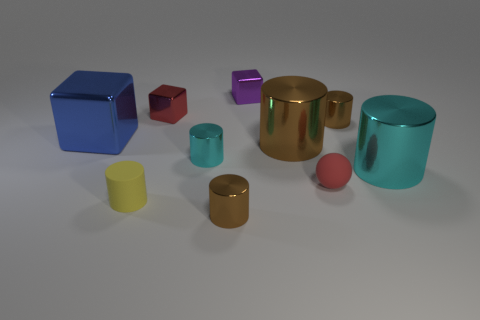Are there fewer blue matte objects than shiny objects?
Give a very brief answer. Yes. There is a red object that is behind the large block; is it the same size as the brown cylinder in front of the red rubber ball?
Give a very brief answer. Yes. What number of things are large cyan matte things or metallic cylinders?
Make the answer very short. 5. There is a cyan metal cylinder left of the tiny purple block; what is its size?
Your response must be concise. Small. What number of big metallic cylinders are to the left of the object that is to the left of the matte thing that is to the left of the purple object?
Make the answer very short. 0. Does the tiny rubber sphere have the same color as the large block?
Make the answer very short. No. What number of metal objects are left of the small red matte thing and behind the blue block?
Provide a succinct answer. 2. There is a large object in front of the small cyan metallic cylinder; what shape is it?
Make the answer very short. Cylinder. Is the number of cubes that are in front of the small cyan object less than the number of small blocks that are in front of the purple metallic cube?
Your answer should be very brief. Yes. Is the material of the small brown cylinder that is to the right of the small ball the same as the red block that is behind the sphere?
Offer a very short reply. Yes. 